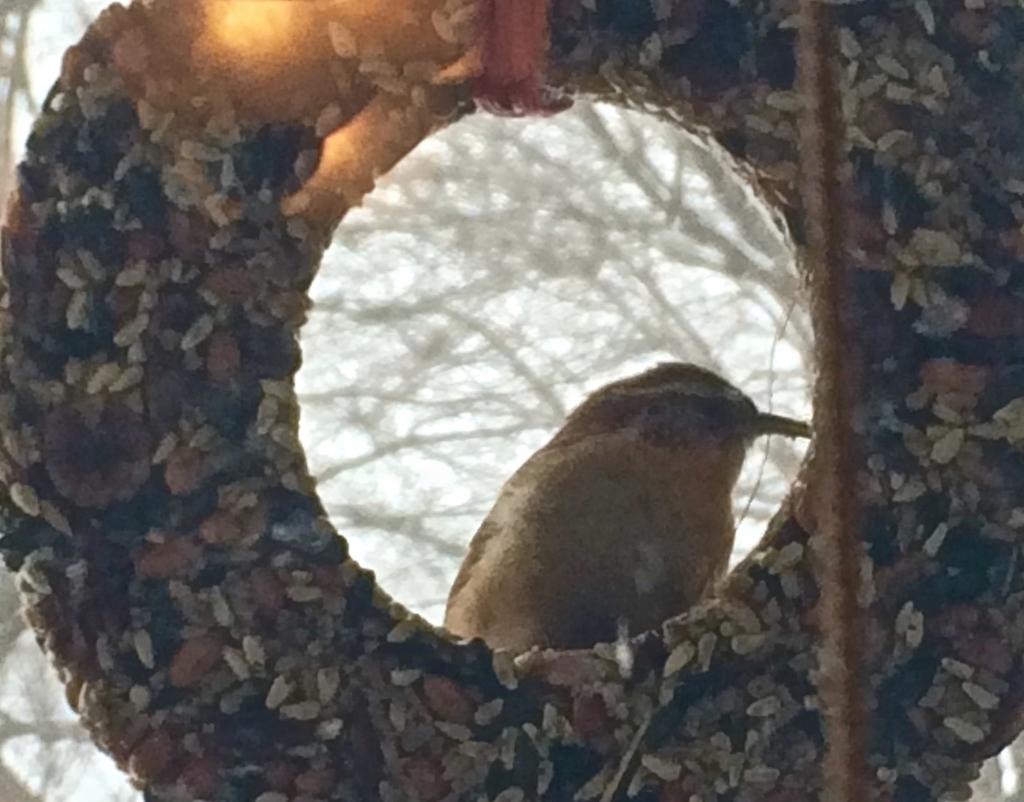What shape is the main object in the image? The main object in the image is circular. What can be seen through the circular object? A bird is visible through the circular object. What type of natural scenery is in the background of the image? There are trees in the background of the image. What type of cow can be seen grazing in the background of the image? There is no cow present in the image; it features a circular object with a bird visible through it, and trees in the background. 